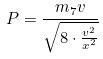Convert formula to latex. <formula><loc_0><loc_0><loc_500><loc_500>P = \frac { m _ { 7 } v } { \sqrt { 8 \cdot \frac { v ^ { 2 } } { x ^ { 2 } } } }</formula> 